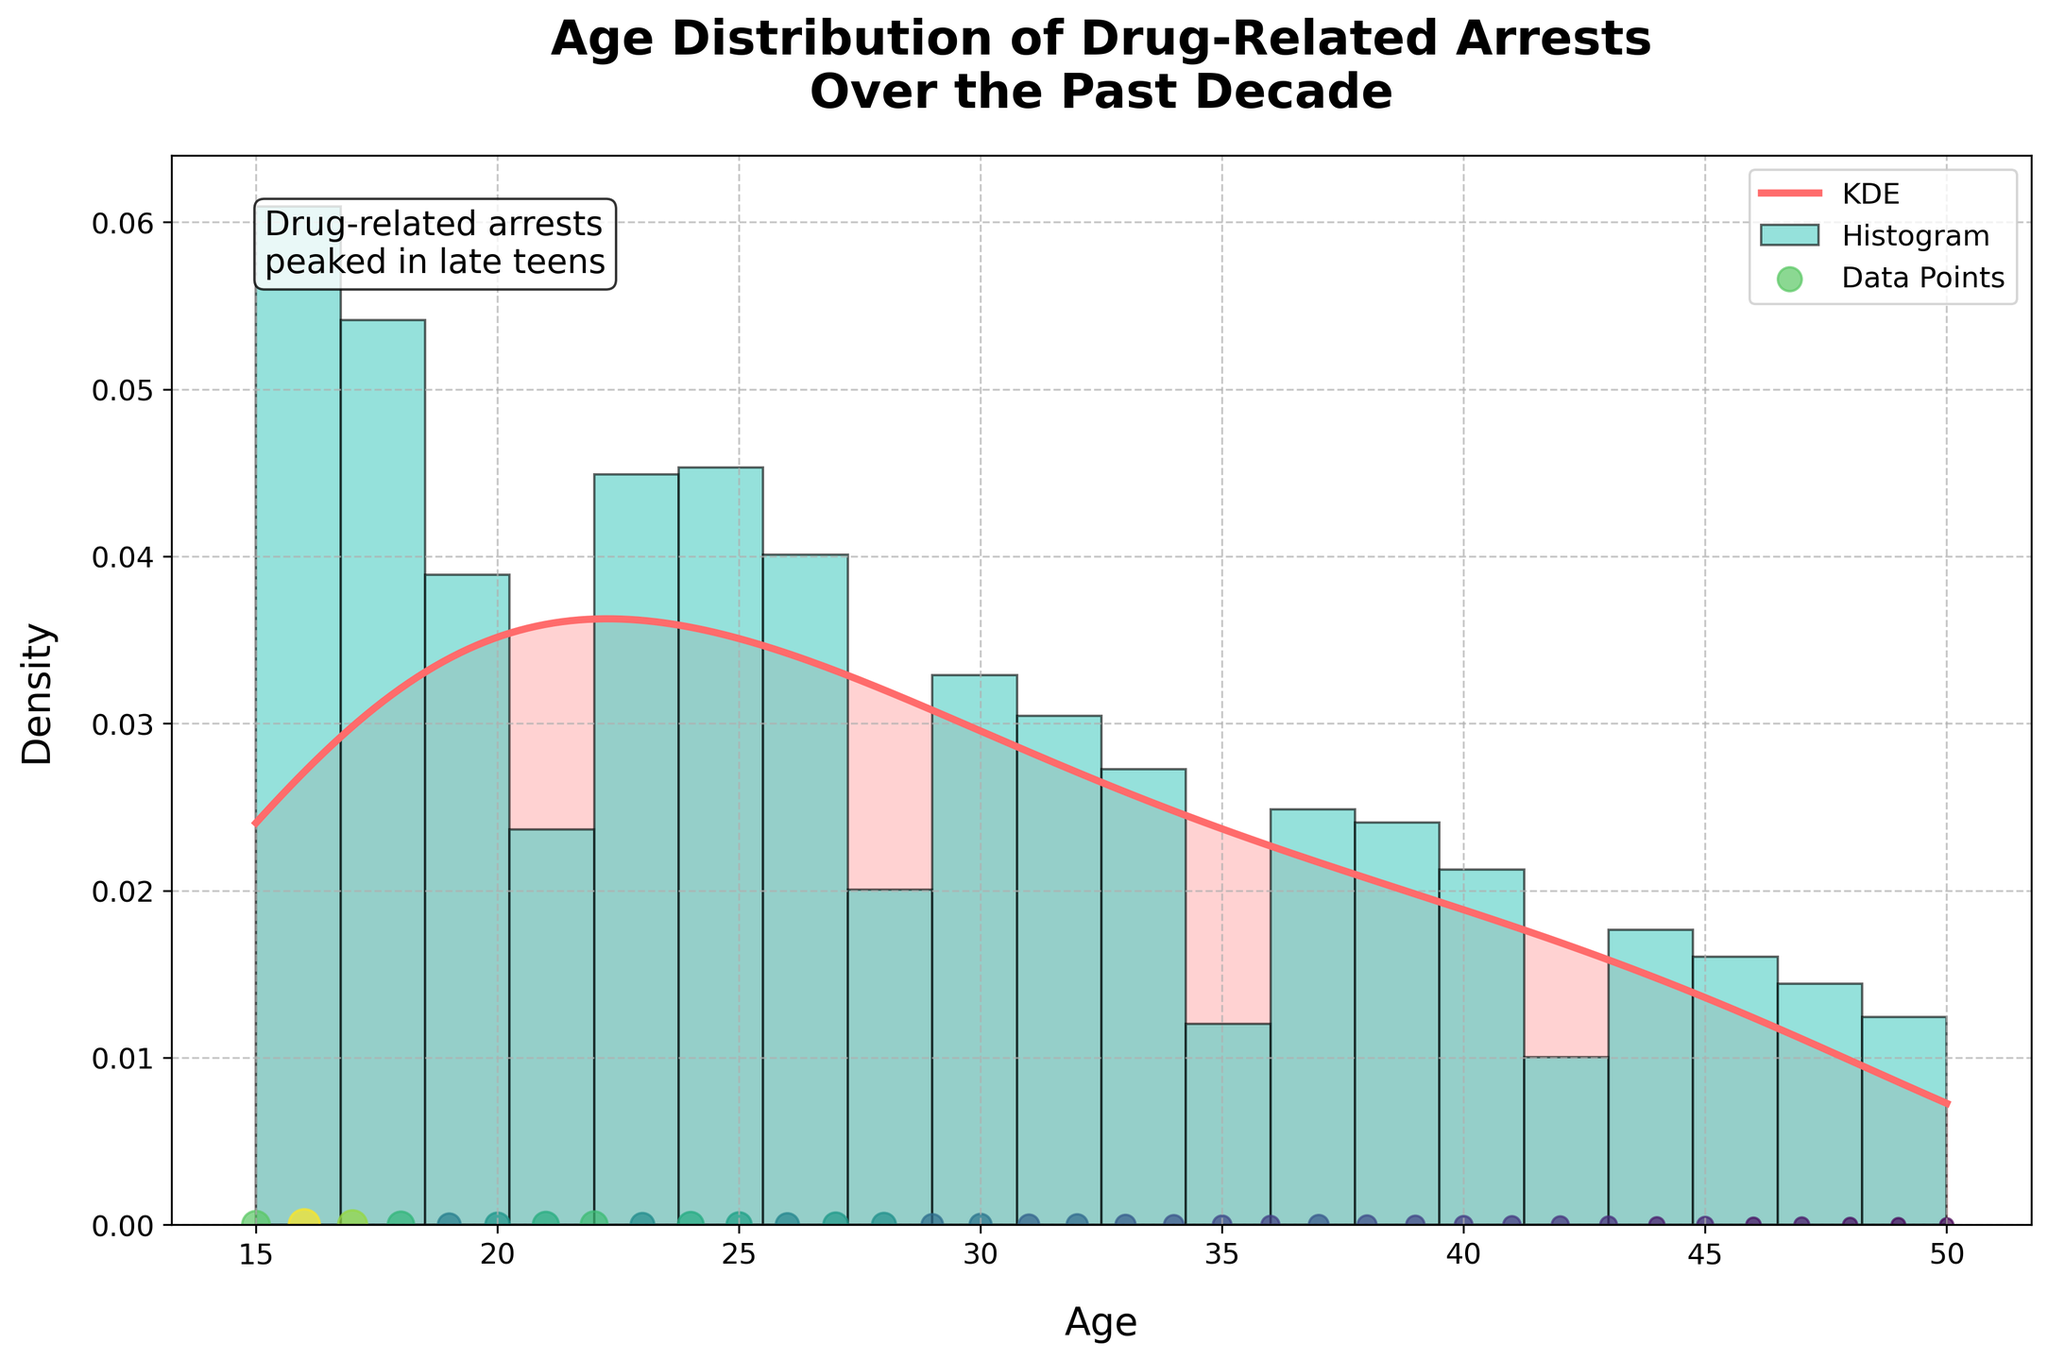What is the title of the plot? The title of the plot is usually displayed at the top of the figure. In this case, the title reads "Age Distribution of Drug-Related Arrests Over the Past Decade".
Answer: Age Distribution of Drug-Related Arrests Over the Past Decade What is the x-axis labeled? The x-axis label is typically displayed below the x-axis and indicates what the horizontal axis represents. For this plot, it is labeled "Age".
Answer: Age What is the y-axis labeled? The y-axis label is usually displayed to the left of the y-axis and indicates what the vertical axis represents. In this figure, it is labeled "Density".
Answer: Density What is the color of the KDE line? The color of the KDE (Kernel Density Estimate) line is typically represented visually in the plot. In this figure, the KDE line is colored in a shade of red.
Answer: Red What is the peak age group in terms of drug-related arrests? The peak age group can be determined by looking at where the KDE line is highest on the x-axis, which indicates the age group with the highest density of arrests. In this figure, the KDE line is highest around the late teens, specifically near age 16-18.
Answer: 16-18 How does the number of arrests vary with age? To find how the number of arrests varies, observe the shape of the KDE line and the histogram. The KDE line and histogram both indicate the frequency of arrests for different ages. Arrests peak around the late teens and then gradually decline as age increases.
Answer: Peaks in late teens and declines Is there a noticeable difference in arrests between ages 30 and 40? By looking at the KDE line and histogram between ages 30 and 40, observe if there are significant changes in height or shape. The plot shows that the density of arrests slightly declines from age 30 to age 40.
Answer: Slight decline How many density peaks are observed in the KDE? To determine the number of peaks, look at the KDE line and count the highest points. The KDE shows a single peak around the late teens.
Answer: One peak What does the text annotation in the plot indicate? The text annotation is usually a small text box on the plot that provides additional insights. In this figure, it notes that drug-related arrests peaked in the late teens.
Answer: Drug-related arrests peaked in late teens Which age group has the lowest number of drug-related arrests? The lowest number of arrests can be determined by looking at both the lowest points on the histogram and KDE line. The plot shows the lowest arrest numbers occur around age 50.
Answer: 50 